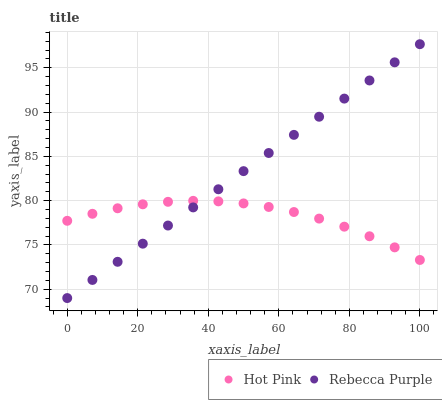Does Hot Pink have the minimum area under the curve?
Answer yes or no. Yes. Does Rebecca Purple have the maximum area under the curve?
Answer yes or no. Yes. Does Rebecca Purple have the minimum area under the curve?
Answer yes or no. No. Is Rebecca Purple the smoothest?
Answer yes or no. Yes. Is Hot Pink the roughest?
Answer yes or no. Yes. Is Rebecca Purple the roughest?
Answer yes or no. No. Does Rebecca Purple have the lowest value?
Answer yes or no. Yes. Does Rebecca Purple have the highest value?
Answer yes or no. Yes. Does Rebecca Purple intersect Hot Pink?
Answer yes or no. Yes. Is Rebecca Purple less than Hot Pink?
Answer yes or no. No. Is Rebecca Purple greater than Hot Pink?
Answer yes or no. No. 